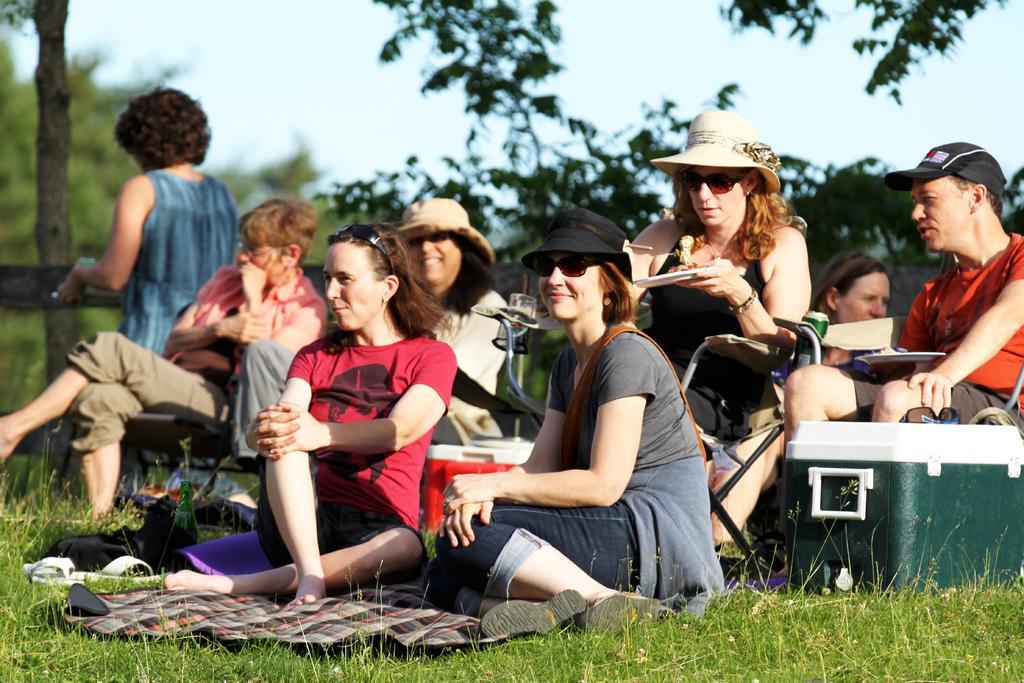How would you summarize this image in a sentence or two? In this picture we can see a group of people where some are sitting on chairs and some are sitting on a cloth, box, bottle, grass and in the background we can see trees, sky. 